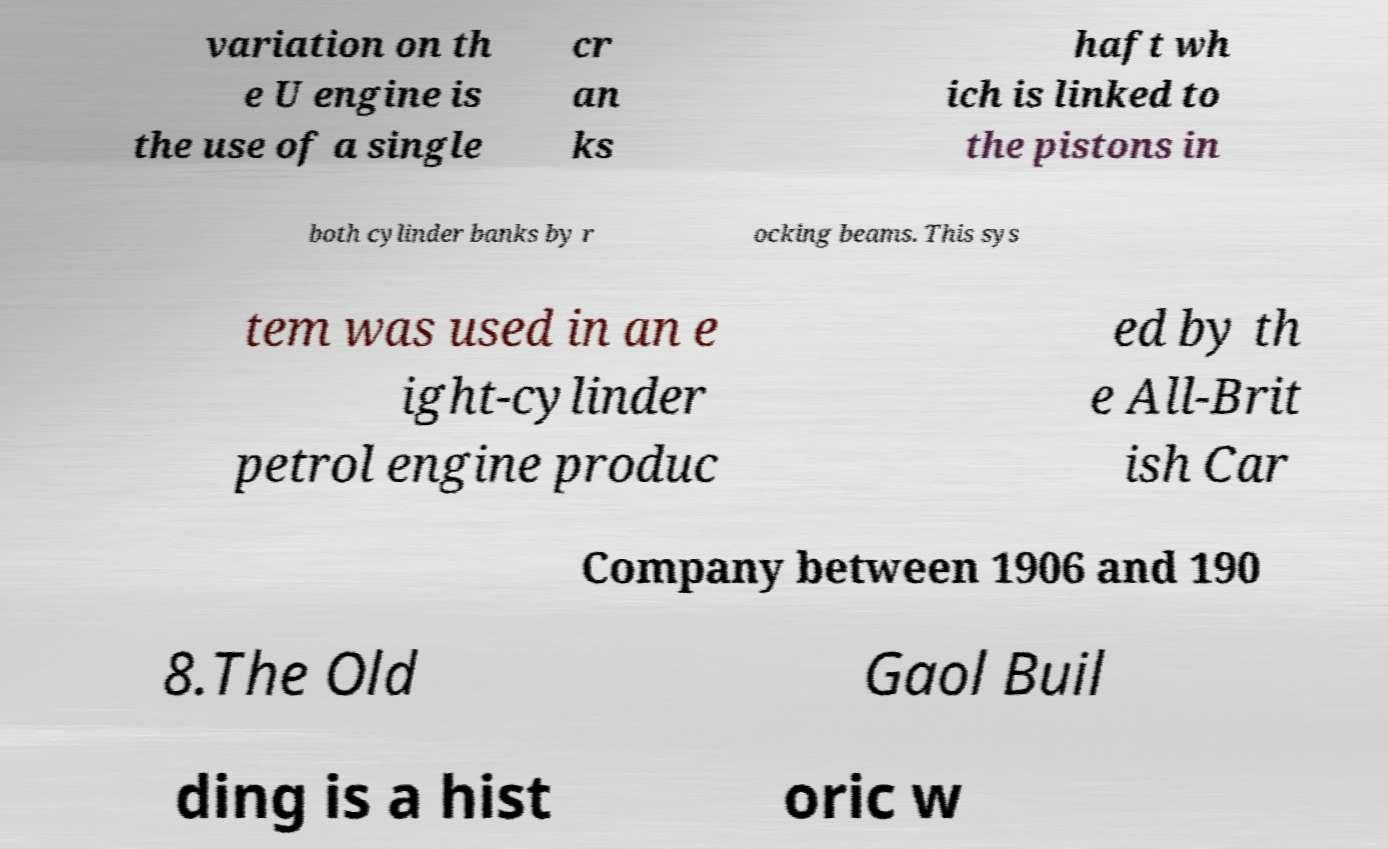I need the written content from this picture converted into text. Can you do that? variation on th e U engine is the use of a single cr an ks haft wh ich is linked to the pistons in both cylinder banks by r ocking beams. This sys tem was used in an e ight-cylinder petrol engine produc ed by th e All-Brit ish Car Company between 1906 and 190 8.The Old Gaol Buil ding is a hist oric w 